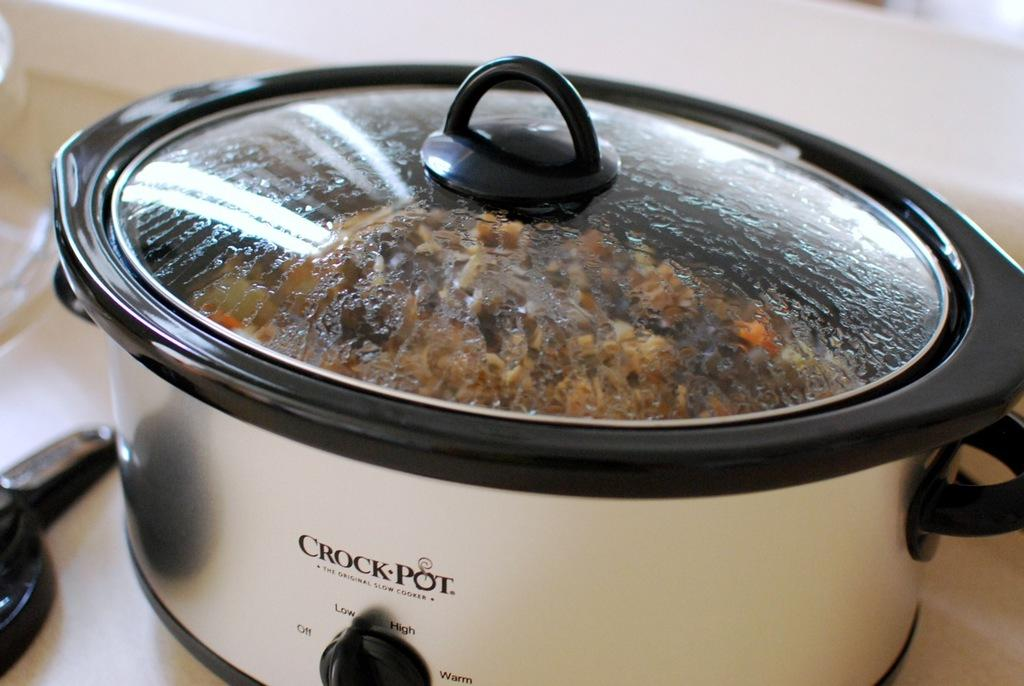Provide a one-sentence caption for the provided image. A crock pot with food in it and a lid on it. 